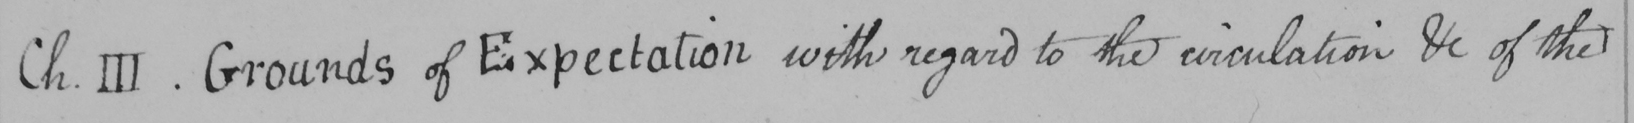Please transcribe the handwritten text in this image. Ch . III . Grounds of Expectation with regard to the circulation etc of the 